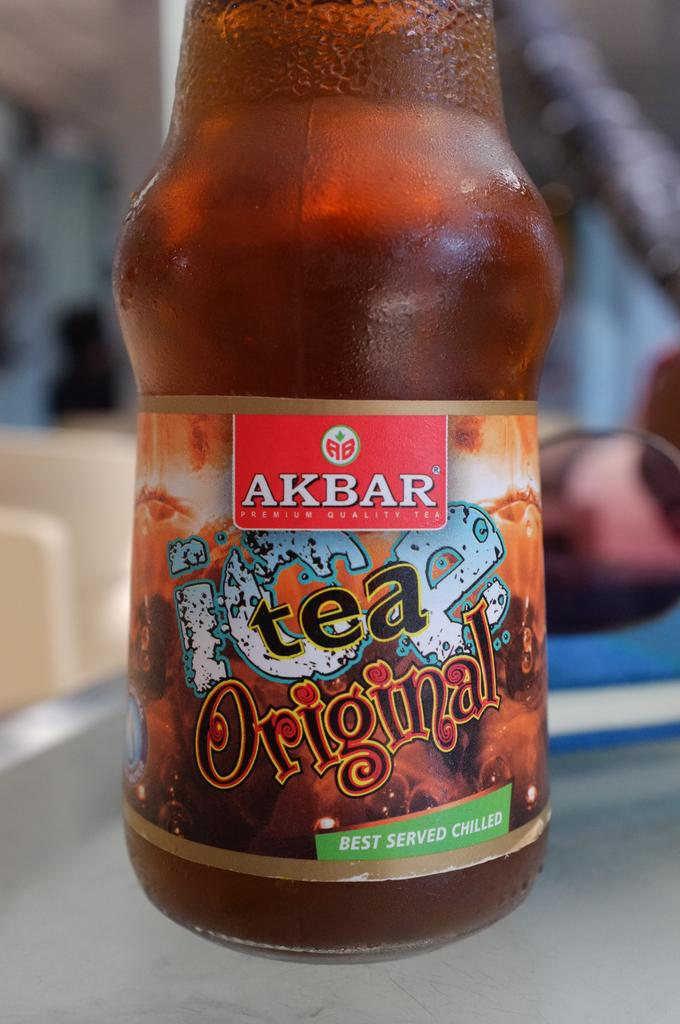What type of container is visible in the image? There is a glass bottle in the image. What color is the bottle? The bottle is brown in color. Is there any text or design on the bottle? Yes, there is a label attached to the bottle. Where is the bottle located in the image? The bottle is placed on a table. Are there any ants running across the property in the image? There is no mention of ants or property in the image; it only features a brown glass bottle on a table. 